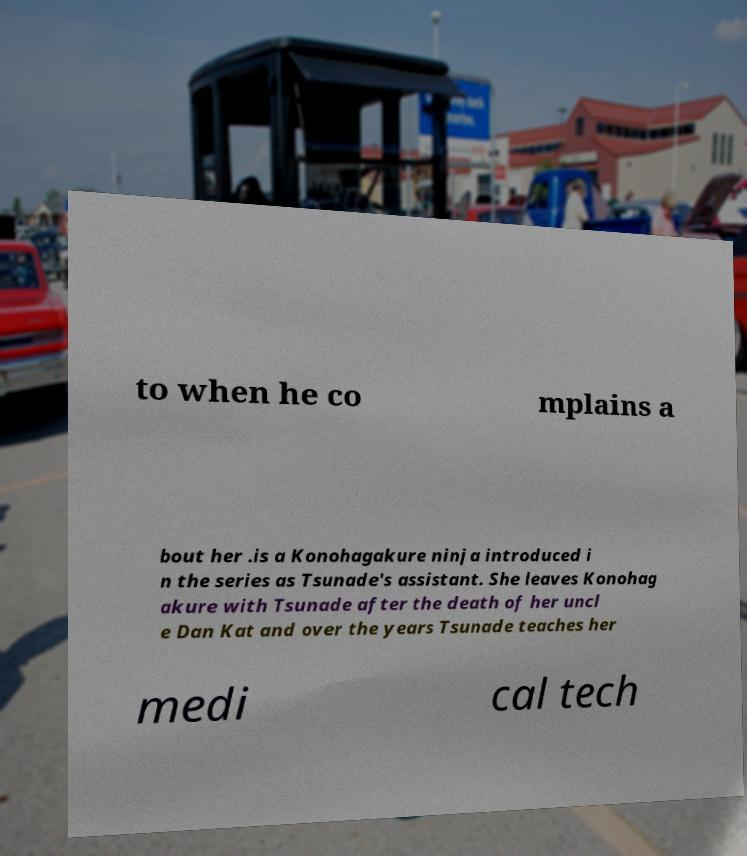I need the written content from this picture converted into text. Can you do that? to when he co mplains a bout her .is a Konohagakure ninja introduced i n the series as Tsunade's assistant. She leaves Konohag akure with Tsunade after the death of her uncl e Dan Kat and over the years Tsunade teaches her medi cal tech 